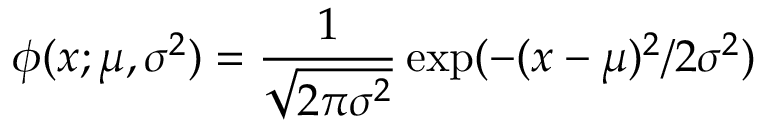<formula> <loc_0><loc_0><loc_500><loc_500>\phi ( x ; \mu , \sigma ^ { 2 } ) = \frac { 1 } { \sqrt { 2 \pi \sigma ^ { 2 } } } \exp ( - ( x - \mu ) ^ { 2 } / 2 \sigma ^ { 2 } )</formula> 